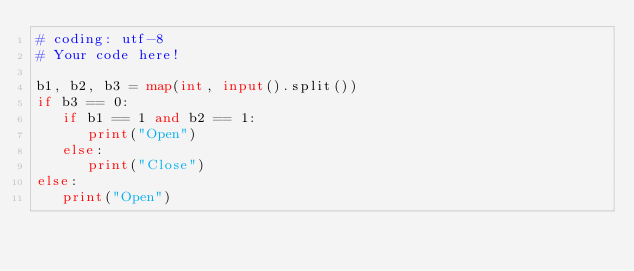Convert code to text. <code><loc_0><loc_0><loc_500><loc_500><_Python_># coding: utf-8
# Your code here!

b1, b2, b3 = map(int, input().split())
if b3 == 0:
   if b1 == 1 and b2 == 1:
      print("Open")
   else:
      print("Close")
else:
   print("Open")

</code> 